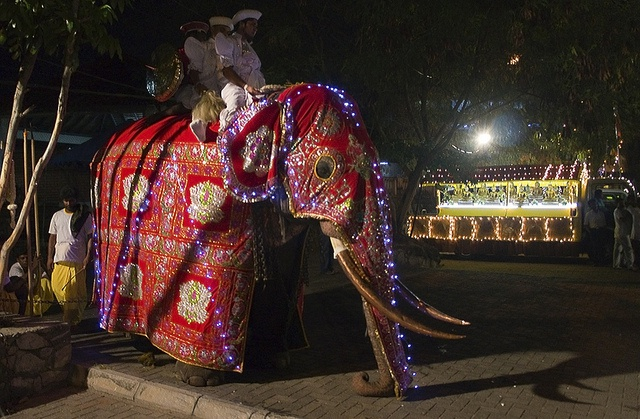Describe the objects in this image and their specific colors. I can see elephant in black, maroon, and brown tones, truck in black, maroon, olive, and white tones, people in black, maroon, and darkgray tones, people in black, maroon, and brown tones, and people in black, gray, and lightgray tones in this image. 